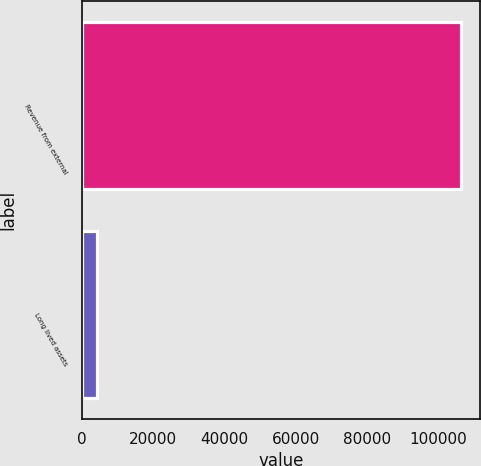Convert chart. <chart><loc_0><loc_0><loc_500><loc_500><bar_chart><fcel>Revenue from external<fcel>Long lived assets<nl><fcel>106343<fcel>4357<nl></chart> 